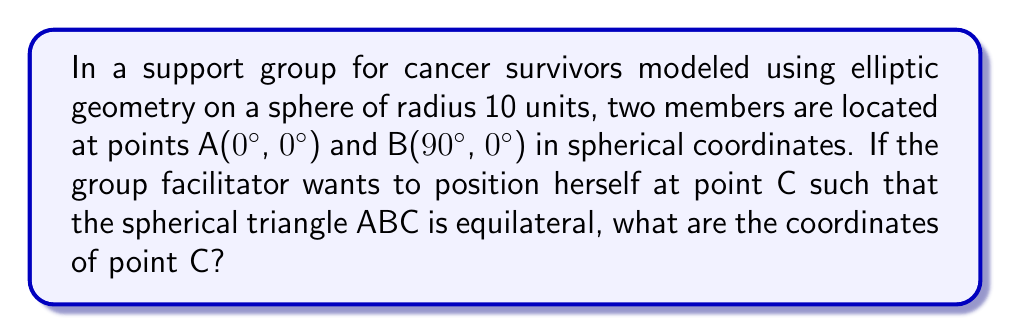Solve this math problem. Let's approach this step-by-step:

1) In elliptic geometry on a sphere, an equilateral triangle has three equal angles and three equal side lengths.

2) The distance between A and B is a quarter of the great circle, which is 90°.

3) For an equilateral spherical triangle, each angle must be 60°. This is because the sum of angles in a spherical triangle is always greater than 180°, and for an equilateral triangle, it's exactly 180° + the spherical excess.

4) The spherical law of cosines for side lengths states:

   $$\cos(a) = \cos(b)\cos(c) + \sin(b)\sin(c)\cos(A)$$

   where $a$, $b$, and $c$ are side lengths, and $A$ is the angle opposite to side $a$.

5) In our case, $a = b = c = 90°$, and $A = 60°$. Substituting these values:

   $$\cos(90°) = \cos(90°)\cos(90°) + \sin(90°)\sin(90°)\cos(60°)$$

6) Simplifying:

   $$0 = 0 + 1 \cdot 1 \cdot \frac{1}{2} = \frac{1}{2}$$

   This confirms our triangle is indeed equilateral.

7) Given A(0°, 0°) and B(90°, 0°), point C must be at (θ, 90°) to form an equilateral triangle.

8) To find θ, we can use the spherical distance formula:

   $$\cos(d) = \sin(\phi_1)\sin(\phi_2) + \cos(\phi_1)\cos(\phi_2)\cos(\Delta\lambda)$$

   where $d$ is the central angle, $\phi$ are latitudes, and $\lambda$ are longitudes.

9) The distance from A to C should be 90°. Substituting known values:

   $$\cos(90°) = \sin(0°)\sin(90°) + \cos(0°)\cos(90°)\cos(\theta)$$

10) Simplifying:

    $$0 = 0 + 0 \cdot \cos(\theta) = 0$$

11) This equation is always true, confirming that C is indeed at (θ, 90°).

12) By symmetry, we can conclude that θ = 90°.

Therefore, the coordinates of point C are (90°, 90°) in spherical coordinates.
Answer: (90°, 90°) 